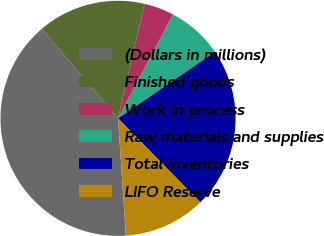Convert chart. <chart><loc_0><loc_0><loc_500><loc_500><pie_chart><fcel>(Dollars in millions)<fcel>Finished goods<fcel>Work in process<fcel>Raw materials and supplies<fcel>Total inventories<fcel>LIFO Reserve<nl><fcel>39.86%<fcel>14.84%<fcel>4.12%<fcel>7.69%<fcel>22.23%<fcel>11.26%<nl></chart> 